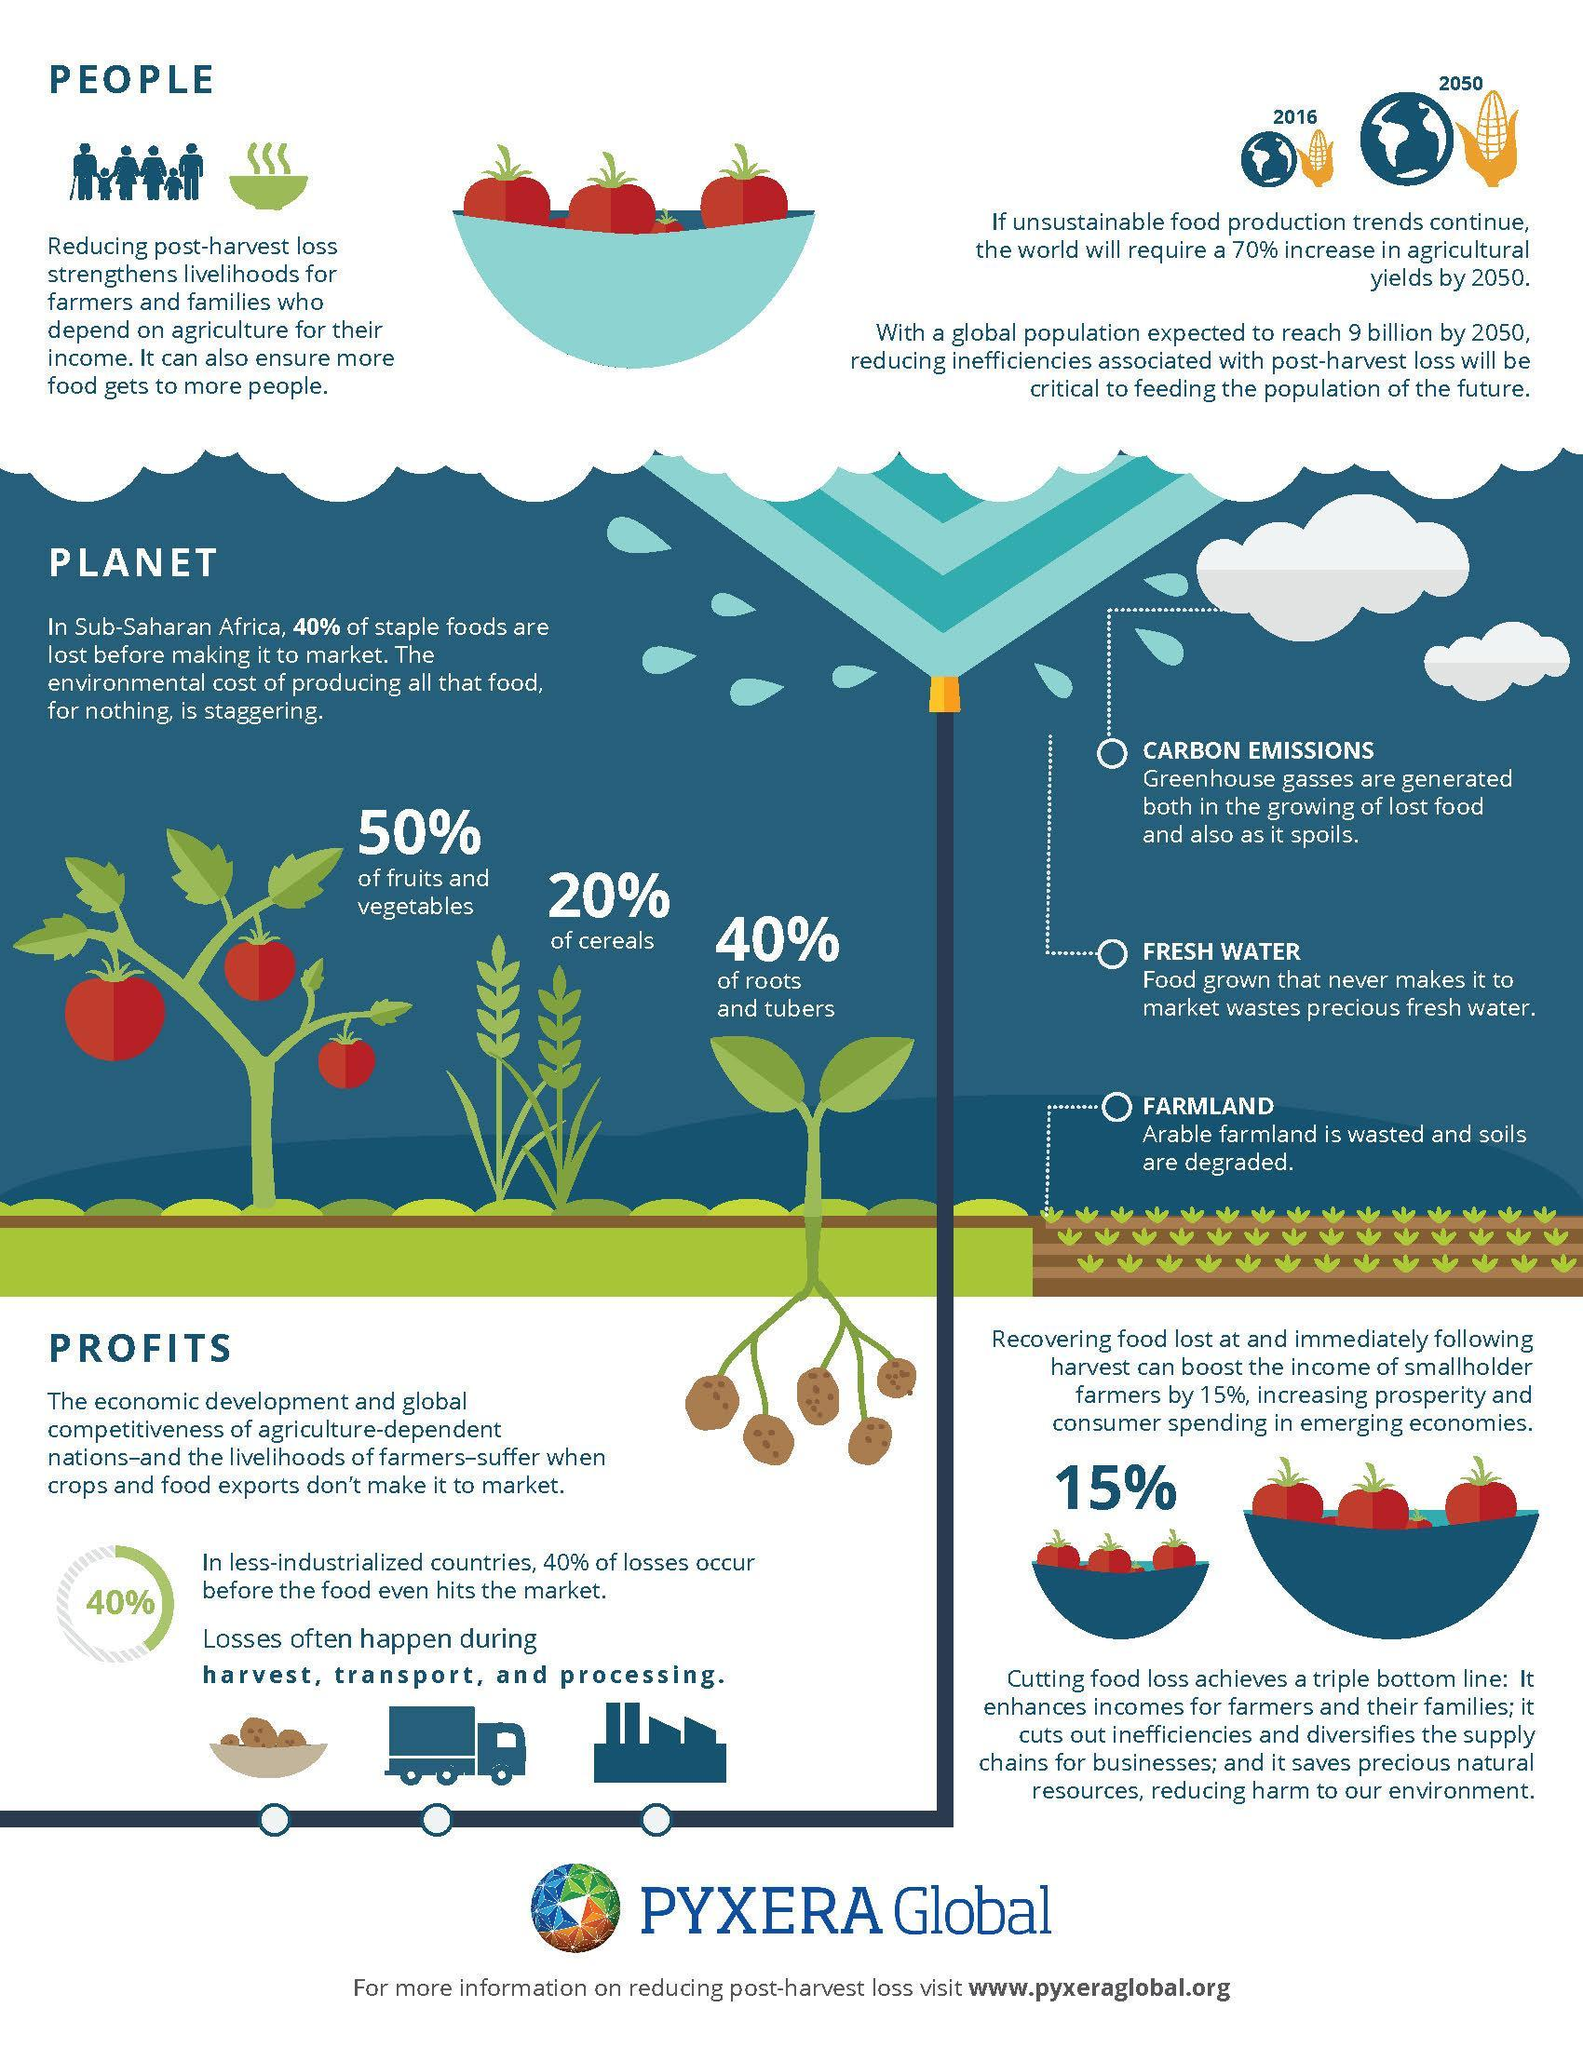What percentage of foods are not cereals?
Answer the question with a short phrase. 80% What percentage of foods are not roots and tubers? 60% 